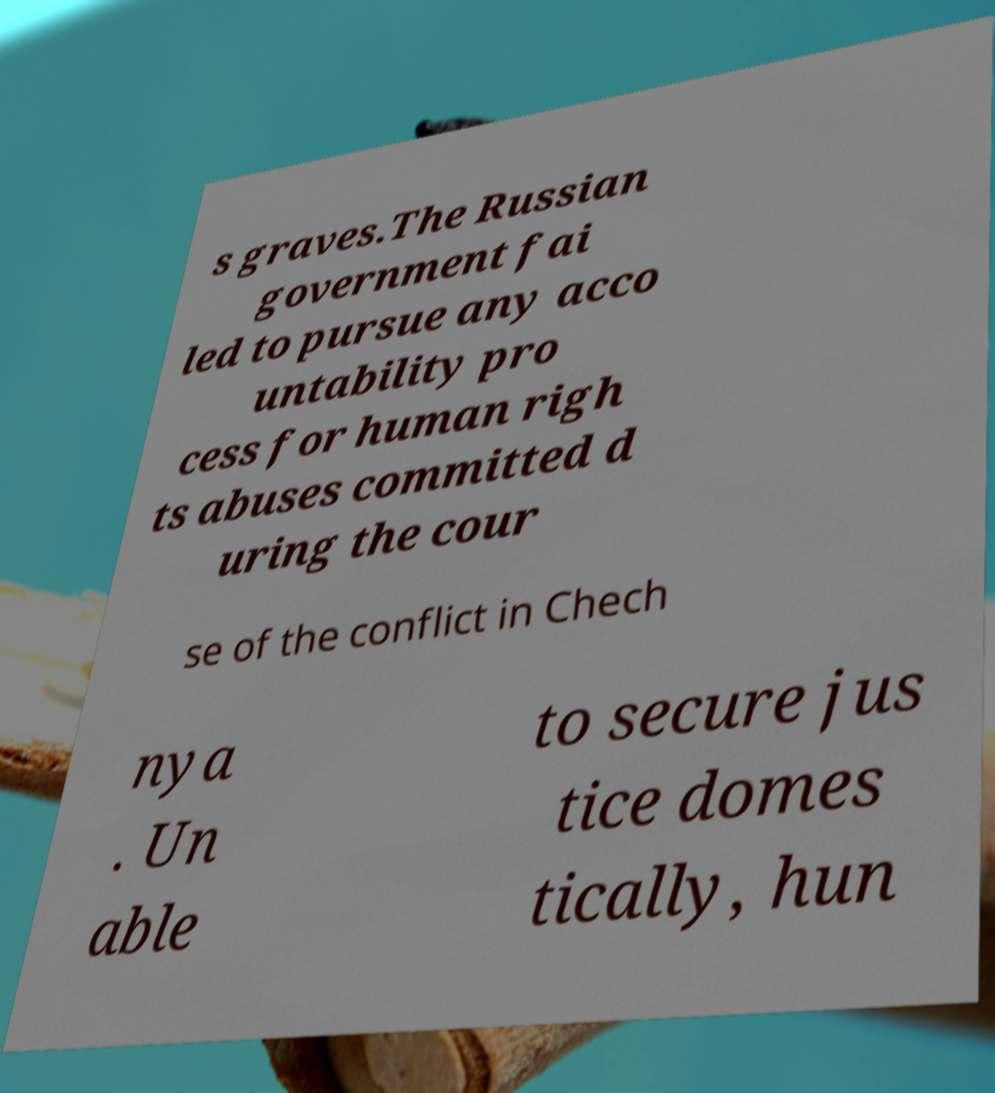Can you accurately transcribe the text from the provided image for me? s graves.The Russian government fai led to pursue any acco untability pro cess for human righ ts abuses committed d uring the cour se of the conflict in Chech nya . Un able to secure jus tice domes tically, hun 